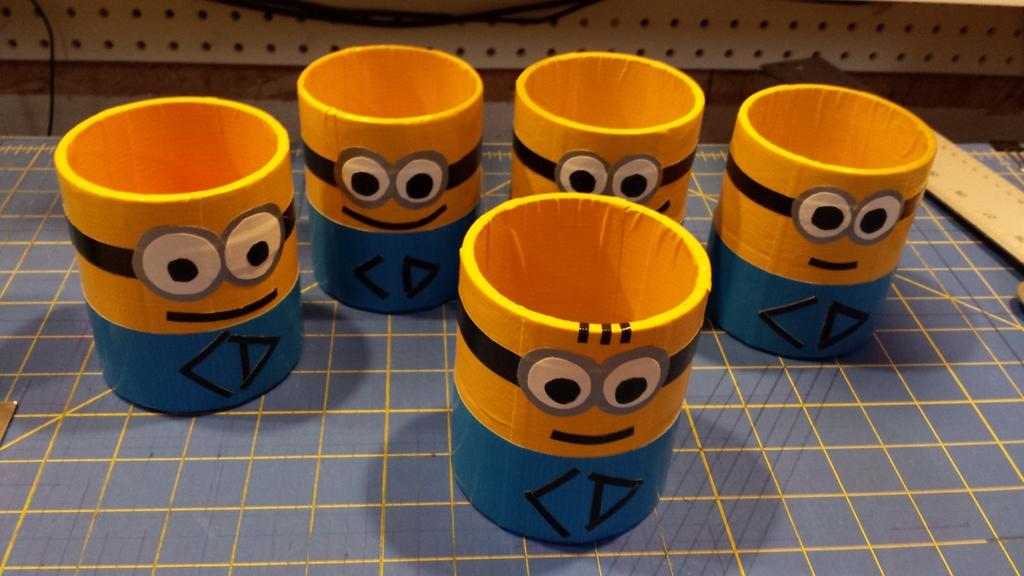How many cups are visible in the image? There are five cups in the image. What colors are the cups? The cups are yellow and blue in color. Is there a volleyball being played in the image? No, there is no volleyball or any indication of a game being played in the image. Can you see a door in the image? The provided facts do not mention a door, so it cannot be determined if one is present in the image. 